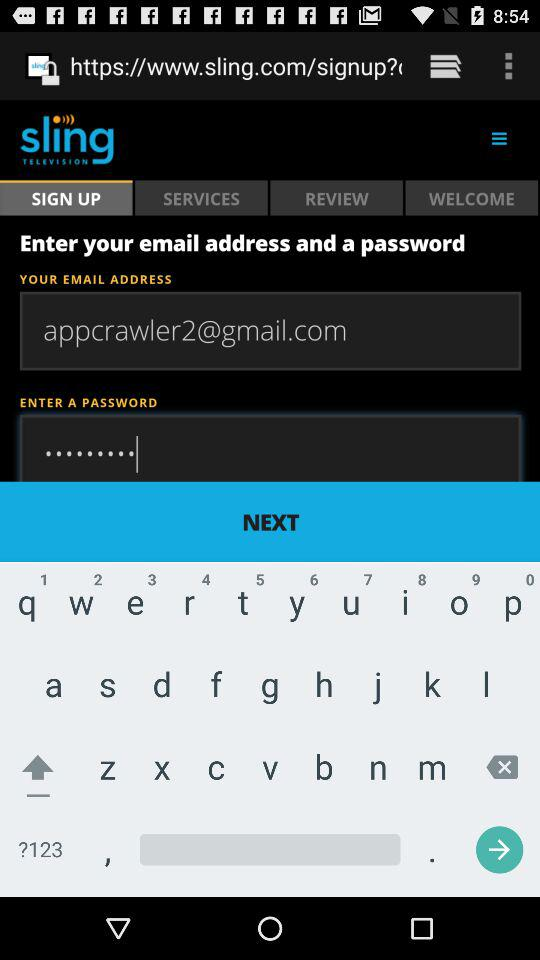What is the email address? The email address is appcrawler2@gmail.con. 